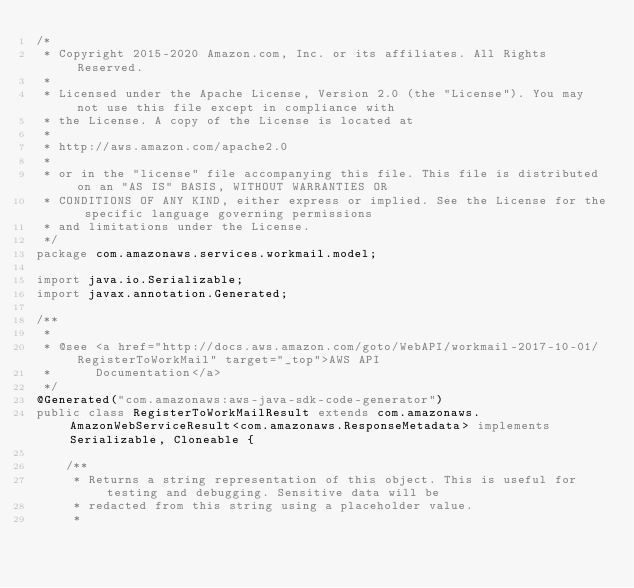Convert code to text. <code><loc_0><loc_0><loc_500><loc_500><_Java_>/*
 * Copyright 2015-2020 Amazon.com, Inc. or its affiliates. All Rights Reserved.
 * 
 * Licensed under the Apache License, Version 2.0 (the "License"). You may not use this file except in compliance with
 * the License. A copy of the License is located at
 * 
 * http://aws.amazon.com/apache2.0
 * 
 * or in the "license" file accompanying this file. This file is distributed on an "AS IS" BASIS, WITHOUT WARRANTIES OR
 * CONDITIONS OF ANY KIND, either express or implied. See the License for the specific language governing permissions
 * and limitations under the License.
 */
package com.amazonaws.services.workmail.model;

import java.io.Serializable;
import javax.annotation.Generated;

/**
 * 
 * @see <a href="http://docs.aws.amazon.com/goto/WebAPI/workmail-2017-10-01/RegisterToWorkMail" target="_top">AWS API
 *      Documentation</a>
 */
@Generated("com.amazonaws:aws-java-sdk-code-generator")
public class RegisterToWorkMailResult extends com.amazonaws.AmazonWebServiceResult<com.amazonaws.ResponseMetadata> implements Serializable, Cloneable {

    /**
     * Returns a string representation of this object. This is useful for testing and debugging. Sensitive data will be
     * redacted from this string using a placeholder value.
     *</code> 